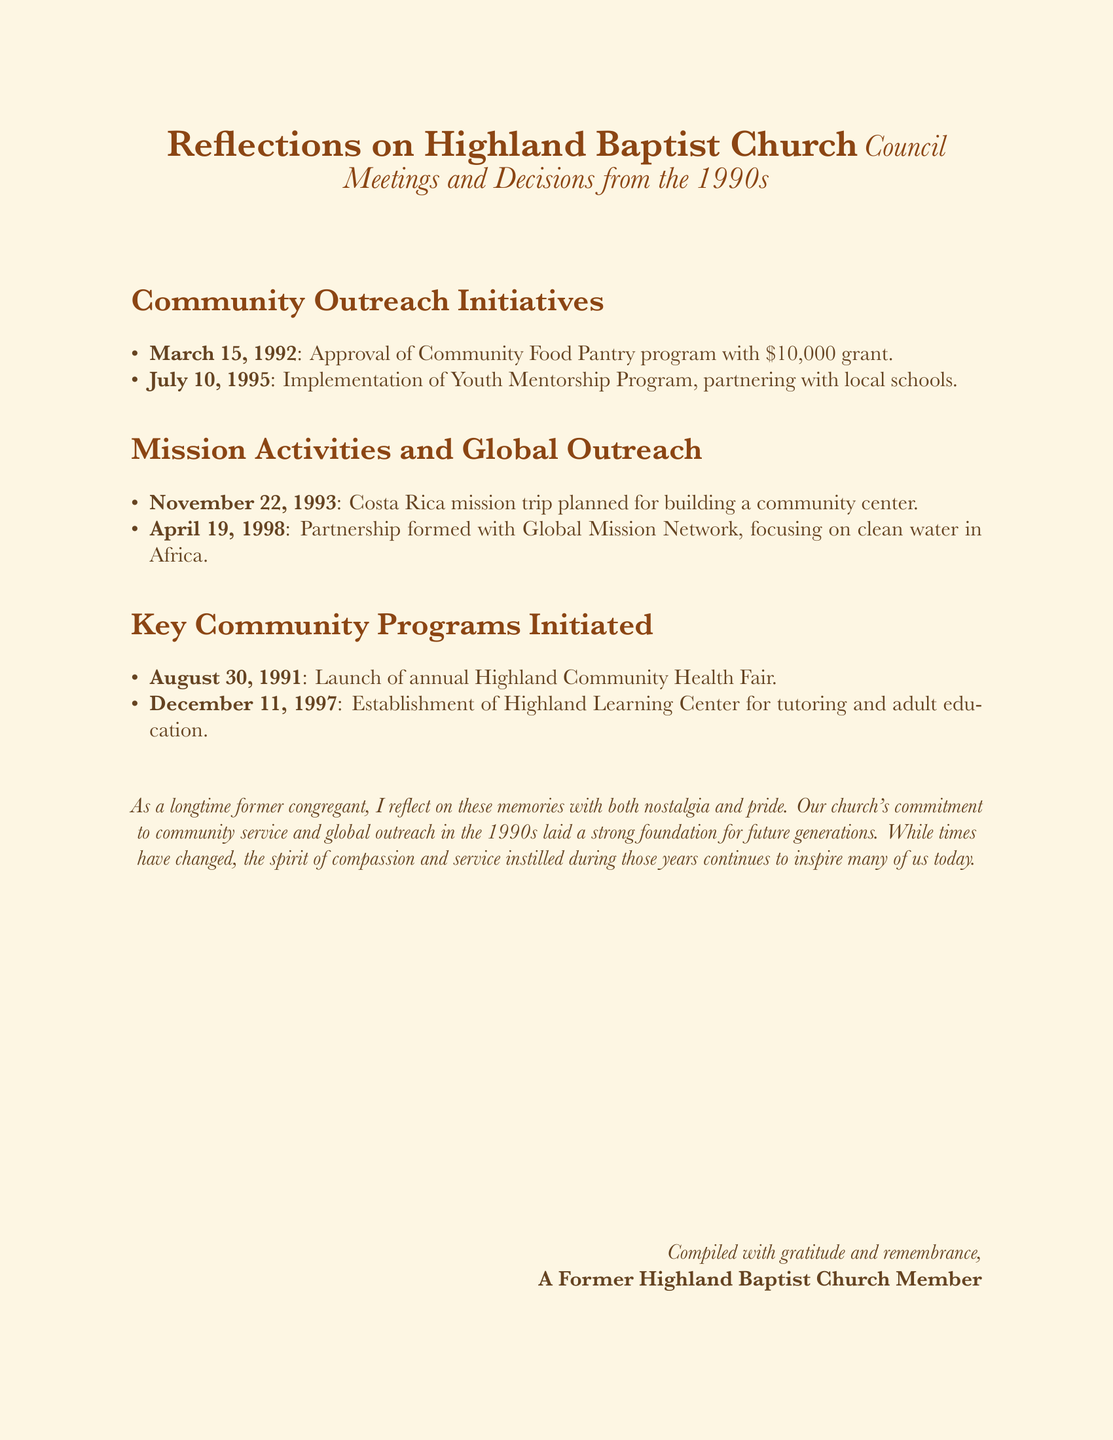What was the grant amount for the Community Food Pantry program? The grant amount approved for the program is mentioned directly in the document as $10,000.
Answer: $10,000 When was the Youth Mentorship Program implemented? The implementation date for the Youth Mentorship Program is clearly stated in the document as July 10, 1995.
Answer: July 10, 1995 What was the mission trip planned for November 22, 1993? The document specifies the mission trip planned for that date as a trip to Costa Rica for building a community center.
Answer: Costa Rica mission trip What focus did the partnership with Global Mission Network have? The document outlines the partnership's focus, which is on clean water in Africa.
Answer: Clean water in Africa Which community program was launched on August 30, 1991? The document directly states that the Highland Community Health Fair was launched on that date.
Answer: Highland Community Health Fair How many key community programs are mentioned in the document? The document lists a total of three key community programs that were initiated, as shown under that section.
Answer: Three What type of programs does the document emphasize from the 1990s? The document emphasizes community outreach and mission activities as the key focus areas from that decade.
Answer: Community outreach and mission activities What is the tone of the final reflection in the document? The tone of the final reflection is sentimentally positive, indicating nostalgia and pride in the church's work.
Answer: Nostalgia and pride 